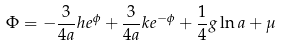Convert formula to latex. <formula><loc_0><loc_0><loc_500><loc_500>\Phi = - \frac { 3 } { 4 a } h e ^ { \phi } + \frac { 3 } { 4 a } k e ^ { - \phi } + \frac { 1 } { 4 } g \ln { a } + \mu</formula> 